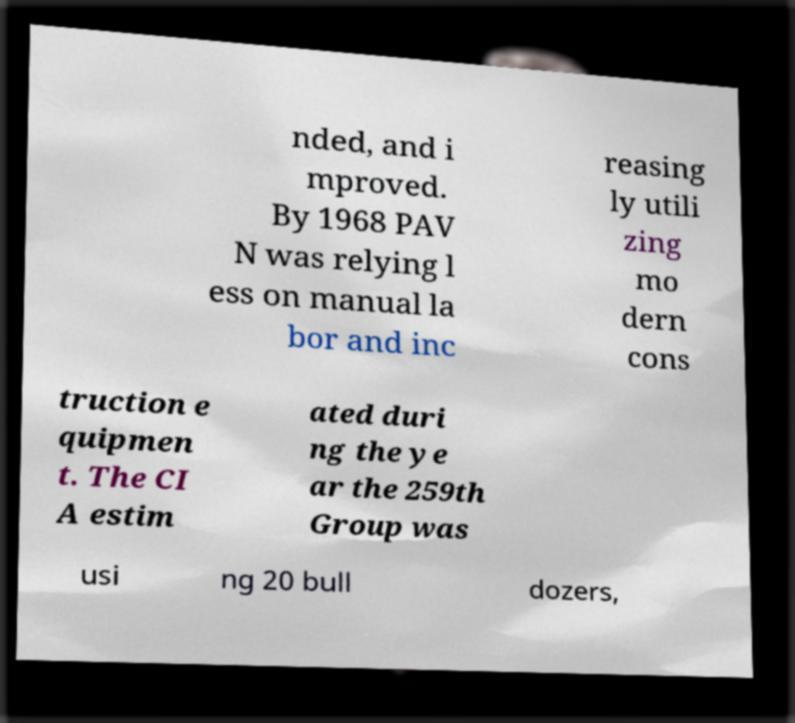Can you read and provide the text displayed in the image?This photo seems to have some interesting text. Can you extract and type it out for me? nded, and i mproved. By 1968 PAV N was relying l ess on manual la bor and inc reasing ly utili zing mo dern cons truction e quipmen t. The CI A estim ated duri ng the ye ar the 259th Group was usi ng 20 bull dozers, 